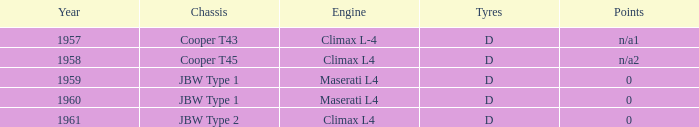What is the engine for a vehicle in 1960? Maserati L4. 